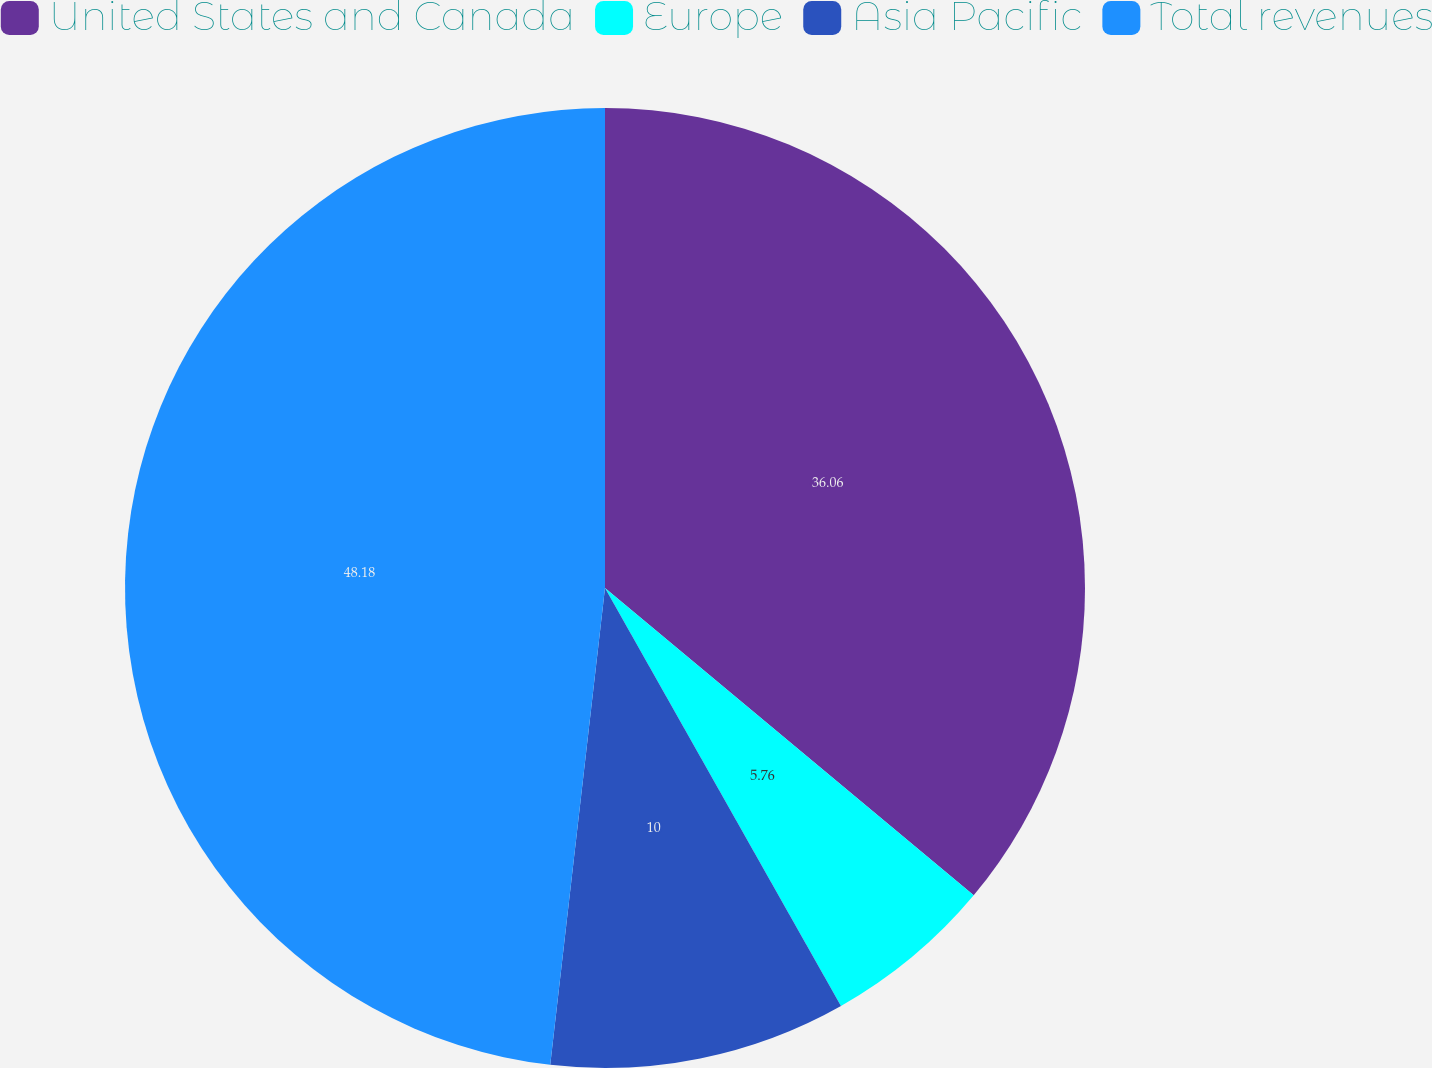Convert chart. <chart><loc_0><loc_0><loc_500><loc_500><pie_chart><fcel>United States and Canada<fcel>Europe<fcel>Asia Pacific<fcel>Total revenues<nl><fcel>36.06%<fcel>5.76%<fcel>10.0%<fcel>48.18%<nl></chart> 